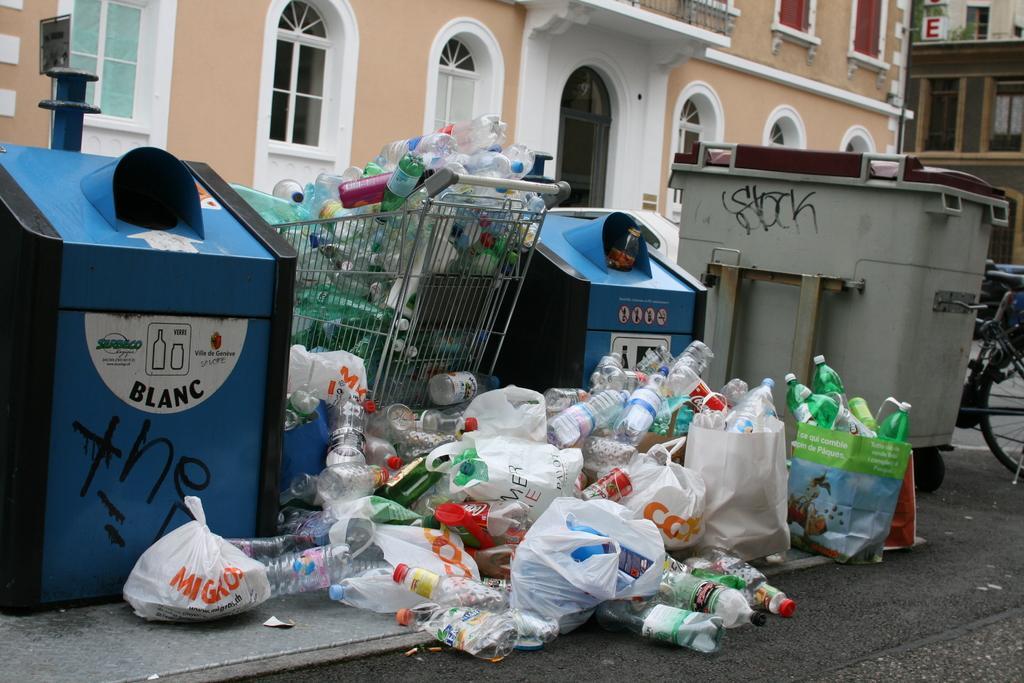Please provide a concise description of this image. In this picture there are three dustbins and a trolley and there are group of plastic bottles where few among them are placed in covers and there is a bicycle in the right corner and there are buildings in the background. 